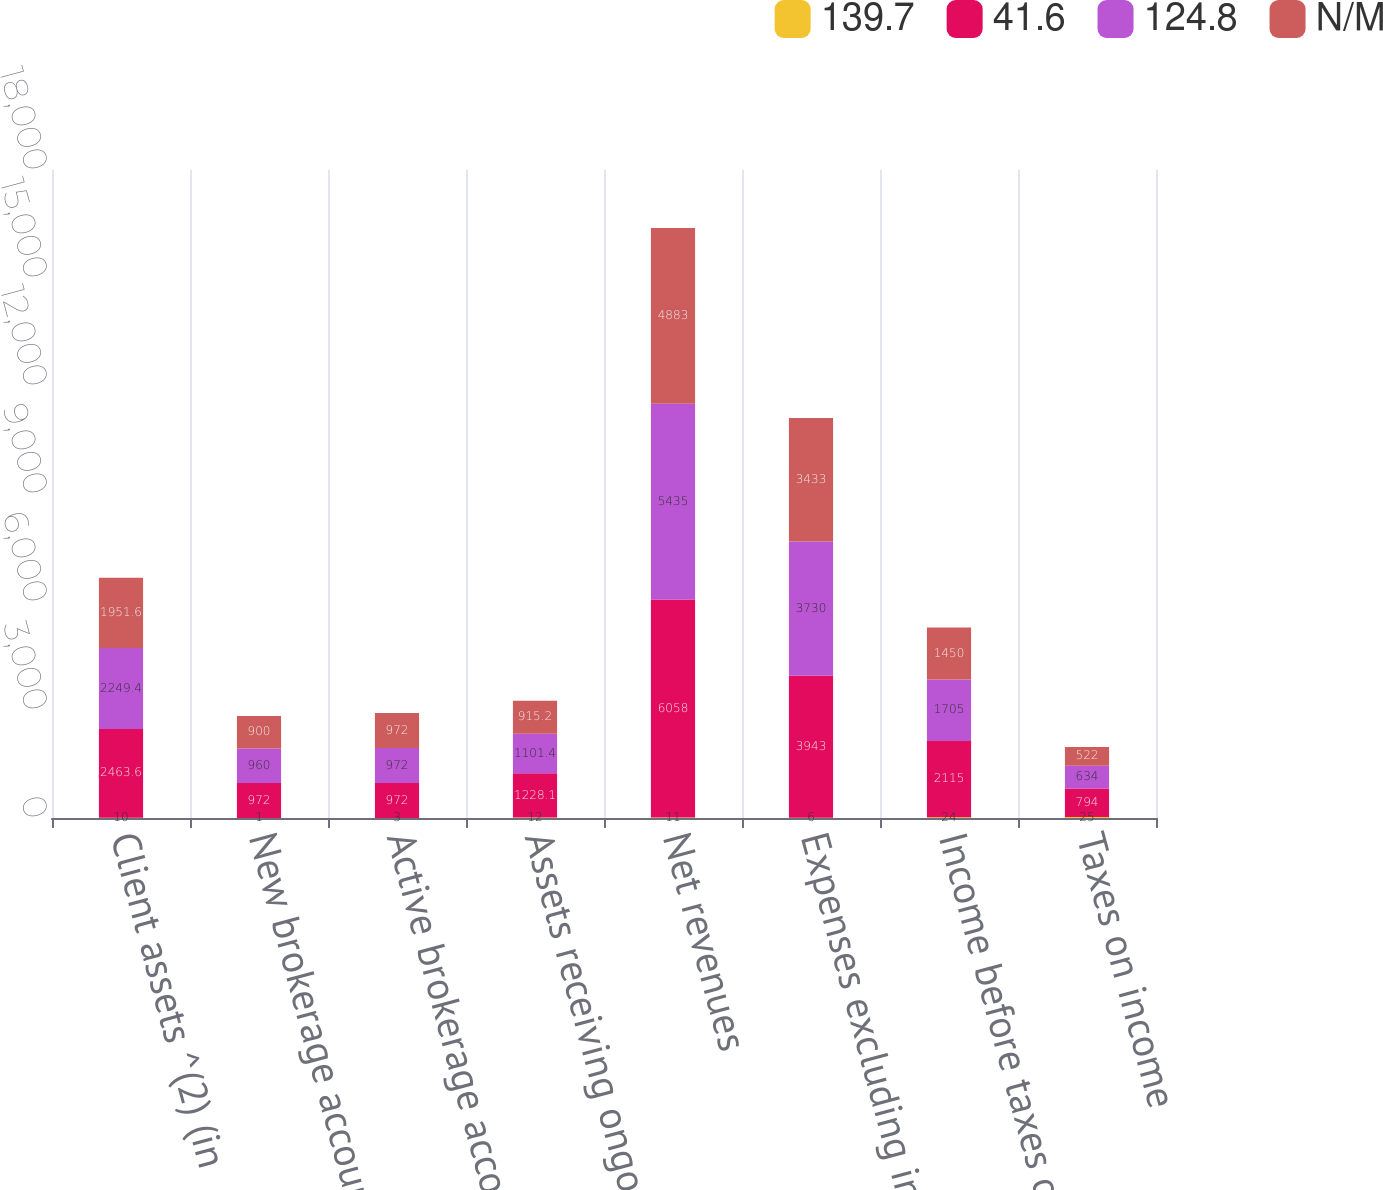Convert chart to OTSL. <chart><loc_0><loc_0><loc_500><loc_500><stacked_bar_chart><ecel><fcel>Client assets ^(2) (in<fcel>New brokerage accounts ^(3)<fcel>Active brokerage accounts ^(4)<fcel>Assets receiving ongoing<fcel>Net revenues<fcel>Expenses excluding interest<fcel>Income before taxes on income<fcel>Taxes on income<nl><fcel>139.7<fcel>10<fcel>1<fcel>3<fcel>12<fcel>11<fcel>6<fcel>24<fcel>25<nl><fcel>41.6<fcel>2463.6<fcel>972<fcel>972<fcel>1228.1<fcel>6058<fcel>3943<fcel>2115<fcel>794<nl><fcel>124.8<fcel>2249.4<fcel>960<fcel>972<fcel>1101.4<fcel>5435<fcel>3730<fcel>1705<fcel>634<nl><fcel>N/M<fcel>1951.6<fcel>900<fcel>972<fcel>915.2<fcel>4883<fcel>3433<fcel>1450<fcel>522<nl></chart> 